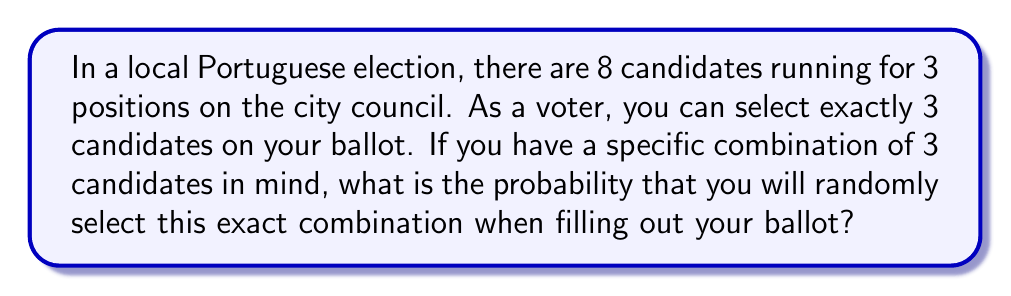Provide a solution to this math problem. Let's approach this step-by-step:

1) First, we need to calculate the total number of possible ways to select 3 candidates out of 8. This is a combination problem, denoted as $\binom{8}{3}$ or C(8,3).

2) The formula for this combination is:

   $$\binom{8}{3} = \frac{8!}{3!(8-3)!} = \frac{8!}{3!5!}$$

3) Let's calculate this:
   $$\frac{8 \cdot 7 \cdot 6 \cdot 5!}{(3 \cdot 2 \cdot 1) \cdot 5!} = \frac{336}{6} = 56$$

4) So there are 56 possible ways to select 3 candidates out of 8.

5) Now, the probability of selecting a specific combination is just 1 out of these 56 possibilities.

6) Therefore, the probability is:

   $$P(\text{specific combination}) = \frac{1}{56}$$

This can also be expressed as a percentage: $\frac{1}{56} \approx 0.0179$ or about 1.79%
Answer: $\frac{1}{56}$ 